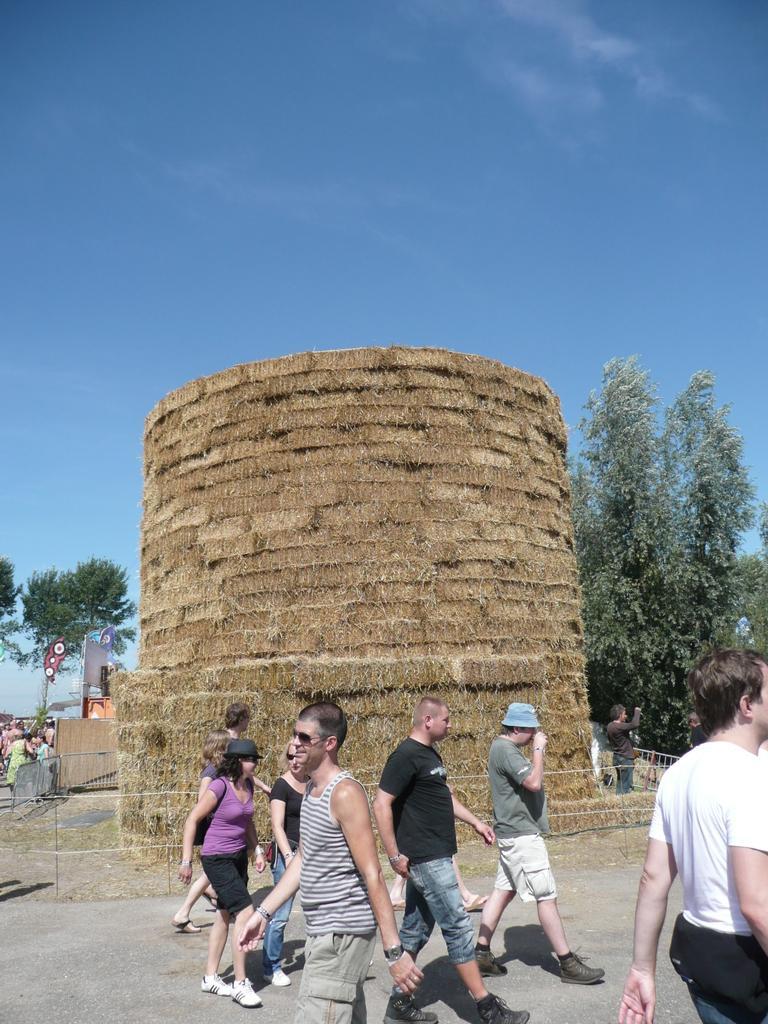Could you give a brief overview of what you see in this image? In this picture I can observe some people walking on the land. In the middle of the picture there is a monument. I can observe a fence in front of the monument. In the background there are trees and a sky. 